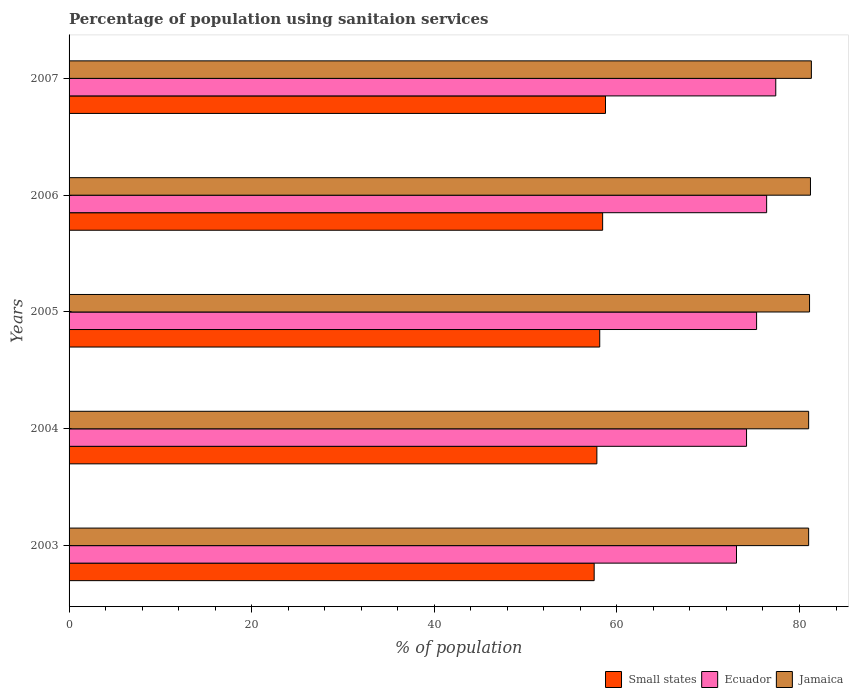How many different coloured bars are there?
Offer a terse response. 3. How many groups of bars are there?
Ensure brevity in your answer.  5. Are the number of bars per tick equal to the number of legend labels?
Keep it short and to the point. Yes. Are the number of bars on each tick of the Y-axis equal?
Ensure brevity in your answer.  Yes. How many bars are there on the 3rd tick from the bottom?
Provide a short and direct response. 3. In how many cases, is the number of bars for a given year not equal to the number of legend labels?
Your response must be concise. 0. What is the percentage of population using sanitaion services in Jamaica in 2006?
Your answer should be very brief. 81.2. Across all years, what is the maximum percentage of population using sanitaion services in Jamaica?
Keep it short and to the point. 81.3. Across all years, what is the minimum percentage of population using sanitaion services in Ecuador?
Give a very brief answer. 73.1. In which year was the percentage of population using sanitaion services in Ecuador maximum?
Make the answer very short. 2007. What is the total percentage of population using sanitaion services in Jamaica in the graph?
Your response must be concise. 405.6. What is the difference between the percentage of population using sanitaion services in Small states in 2005 and that in 2007?
Offer a very short reply. -0.63. What is the difference between the percentage of population using sanitaion services in Small states in 2006 and the percentage of population using sanitaion services in Ecuador in 2005?
Your answer should be very brief. -16.86. What is the average percentage of population using sanitaion services in Jamaica per year?
Make the answer very short. 81.12. In the year 2004, what is the difference between the percentage of population using sanitaion services in Jamaica and percentage of population using sanitaion services in Ecuador?
Your answer should be very brief. 6.8. In how many years, is the percentage of population using sanitaion services in Jamaica greater than 20 %?
Your answer should be compact. 5. What is the ratio of the percentage of population using sanitaion services in Small states in 2004 to that in 2006?
Offer a terse response. 0.99. What is the difference between the highest and the second highest percentage of population using sanitaion services in Small states?
Make the answer very short. 0.31. What is the difference between the highest and the lowest percentage of population using sanitaion services in Ecuador?
Keep it short and to the point. 4.3. What does the 2nd bar from the top in 2005 represents?
Your answer should be very brief. Ecuador. What does the 1st bar from the bottom in 2003 represents?
Provide a succinct answer. Small states. Does the graph contain grids?
Your response must be concise. No. Where does the legend appear in the graph?
Your answer should be very brief. Bottom right. What is the title of the graph?
Your answer should be very brief. Percentage of population using sanitaion services. What is the label or title of the X-axis?
Provide a succinct answer. % of population. What is the % of population of Small states in 2003?
Your answer should be compact. 57.51. What is the % of population of Ecuador in 2003?
Keep it short and to the point. 73.1. What is the % of population in Jamaica in 2003?
Your response must be concise. 81. What is the % of population in Small states in 2004?
Your response must be concise. 57.81. What is the % of population of Ecuador in 2004?
Your answer should be compact. 74.2. What is the % of population in Small states in 2005?
Give a very brief answer. 58.12. What is the % of population in Ecuador in 2005?
Your response must be concise. 75.3. What is the % of population of Jamaica in 2005?
Your answer should be very brief. 81.1. What is the % of population in Small states in 2006?
Keep it short and to the point. 58.44. What is the % of population of Ecuador in 2006?
Ensure brevity in your answer.  76.4. What is the % of population of Jamaica in 2006?
Provide a short and direct response. 81.2. What is the % of population of Small states in 2007?
Your response must be concise. 58.75. What is the % of population in Ecuador in 2007?
Keep it short and to the point. 77.4. What is the % of population in Jamaica in 2007?
Keep it short and to the point. 81.3. Across all years, what is the maximum % of population of Small states?
Keep it short and to the point. 58.75. Across all years, what is the maximum % of population of Ecuador?
Your response must be concise. 77.4. Across all years, what is the maximum % of population in Jamaica?
Your answer should be compact. 81.3. Across all years, what is the minimum % of population in Small states?
Your answer should be very brief. 57.51. Across all years, what is the minimum % of population in Ecuador?
Provide a succinct answer. 73.1. What is the total % of population of Small states in the graph?
Keep it short and to the point. 290.63. What is the total % of population in Ecuador in the graph?
Provide a succinct answer. 376.4. What is the total % of population in Jamaica in the graph?
Your answer should be compact. 405.6. What is the difference between the % of population of Small states in 2003 and that in 2004?
Keep it short and to the point. -0.3. What is the difference between the % of population of Small states in 2003 and that in 2005?
Your answer should be very brief. -0.61. What is the difference between the % of population of Ecuador in 2003 and that in 2005?
Keep it short and to the point. -2.2. What is the difference between the % of population in Jamaica in 2003 and that in 2005?
Keep it short and to the point. -0.1. What is the difference between the % of population of Small states in 2003 and that in 2006?
Keep it short and to the point. -0.93. What is the difference between the % of population of Jamaica in 2003 and that in 2006?
Provide a succinct answer. -0.2. What is the difference between the % of population in Small states in 2003 and that in 2007?
Your response must be concise. -1.24. What is the difference between the % of population of Ecuador in 2003 and that in 2007?
Your response must be concise. -4.3. What is the difference between the % of population of Jamaica in 2003 and that in 2007?
Your answer should be very brief. -0.3. What is the difference between the % of population of Small states in 2004 and that in 2005?
Offer a very short reply. -0.31. What is the difference between the % of population in Ecuador in 2004 and that in 2005?
Offer a terse response. -1.1. What is the difference between the % of population in Jamaica in 2004 and that in 2005?
Ensure brevity in your answer.  -0.1. What is the difference between the % of population of Small states in 2004 and that in 2006?
Your response must be concise. -0.63. What is the difference between the % of population in Ecuador in 2004 and that in 2006?
Keep it short and to the point. -2.2. What is the difference between the % of population in Small states in 2004 and that in 2007?
Offer a very short reply. -0.95. What is the difference between the % of population in Ecuador in 2004 and that in 2007?
Provide a succinct answer. -3.2. What is the difference between the % of population in Small states in 2005 and that in 2006?
Your response must be concise. -0.32. What is the difference between the % of population in Ecuador in 2005 and that in 2006?
Provide a short and direct response. -1.1. What is the difference between the % of population in Small states in 2005 and that in 2007?
Your answer should be compact. -0.63. What is the difference between the % of population in Small states in 2006 and that in 2007?
Make the answer very short. -0.31. What is the difference between the % of population of Ecuador in 2006 and that in 2007?
Keep it short and to the point. -1. What is the difference between the % of population in Jamaica in 2006 and that in 2007?
Keep it short and to the point. -0.1. What is the difference between the % of population in Small states in 2003 and the % of population in Ecuador in 2004?
Your response must be concise. -16.69. What is the difference between the % of population of Small states in 2003 and the % of population of Jamaica in 2004?
Ensure brevity in your answer.  -23.49. What is the difference between the % of population in Small states in 2003 and the % of population in Ecuador in 2005?
Your response must be concise. -17.79. What is the difference between the % of population in Small states in 2003 and the % of population in Jamaica in 2005?
Make the answer very short. -23.59. What is the difference between the % of population in Small states in 2003 and the % of population in Ecuador in 2006?
Offer a very short reply. -18.89. What is the difference between the % of population of Small states in 2003 and the % of population of Jamaica in 2006?
Ensure brevity in your answer.  -23.69. What is the difference between the % of population of Small states in 2003 and the % of population of Ecuador in 2007?
Provide a short and direct response. -19.89. What is the difference between the % of population in Small states in 2003 and the % of population in Jamaica in 2007?
Your answer should be compact. -23.79. What is the difference between the % of population in Small states in 2004 and the % of population in Ecuador in 2005?
Your answer should be compact. -17.49. What is the difference between the % of population in Small states in 2004 and the % of population in Jamaica in 2005?
Provide a short and direct response. -23.29. What is the difference between the % of population of Ecuador in 2004 and the % of population of Jamaica in 2005?
Your answer should be compact. -6.9. What is the difference between the % of population in Small states in 2004 and the % of population in Ecuador in 2006?
Give a very brief answer. -18.59. What is the difference between the % of population in Small states in 2004 and the % of population in Jamaica in 2006?
Give a very brief answer. -23.39. What is the difference between the % of population of Ecuador in 2004 and the % of population of Jamaica in 2006?
Ensure brevity in your answer.  -7. What is the difference between the % of population in Small states in 2004 and the % of population in Ecuador in 2007?
Give a very brief answer. -19.59. What is the difference between the % of population in Small states in 2004 and the % of population in Jamaica in 2007?
Ensure brevity in your answer.  -23.49. What is the difference between the % of population of Ecuador in 2004 and the % of population of Jamaica in 2007?
Ensure brevity in your answer.  -7.1. What is the difference between the % of population in Small states in 2005 and the % of population in Ecuador in 2006?
Give a very brief answer. -18.28. What is the difference between the % of population in Small states in 2005 and the % of population in Jamaica in 2006?
Make the answer very short. -23.08. What is the difference between the % of population of Small states in 2005 and the % of population of Ecuador in 2007?
Make the answer very short. -19.28. What is the difference between the % of population of Small states in 2005 and the % of population of Jamaica in 2007?
Give a very brief answer. -23.18. What is the difference between the % of population of Small states in 2006 and the % of population of Ecuador in 2007?
Ensure brevity in your answer.  -18.96. What is the difference between the % of population of Small states in 2006 and the % of population of Jamaica in 2007?
Ensure brevity in your answer.  -22.86. What is the difference between the % of population of Ecuador in 2006 and the % of population of Jamaica in 2007?
Your answer should be compact. -4.9. What is the average % of population in Small states per year?
Offer a terse response. 58.13. What is the average % of population of Ecuador per year?
Offer a very short reply. 75.28. What is the average % of population of Jamaica per year?
Offer a very short reply. 81.12. In the year 2003, what is the difference between the % of population of Small states and % of population of Ecuador?
Your answer should be very brief. -15.59. In the year 2003, what is the difference between the % of population in Small states and % of population in Jamaica?
Ensure brevity in your answer.  -23.49. In the year 2004, what is the difference between the % of population in Small states and % of population in Ecuador?
Keep it short and to the point. -16.39. In the year 2004, what is the difference between the % of population in Small states and % of population in Jamaica?
Your answer should be very brief. -23.19. In the year 2004, what is the difference between the % of population in Ecuador and % of population in Jamaica?
Provide a succinct answer. -6.8. In the year 2005, what is the difference between the % of population of Small states and % of population of Ecuador?
Your answer should be compact. -17.18. In the year 2005, what is the difference between the % of population of Small states and % of population of Jamaica?
Your response must be concise. -22.98. In the year 2005, what is the difference between the % of population of Ecuador and % of population of Jamaica?
Provide a short and direct response. -5.8. In the year 2006, what is the difference between the % of population of Small states and % of population of Ecuador?
Ensure brevity in your answer.  -17.96. In the year 2006, what is the difference between the % of population of Small states and % of population of Jamaica?
Your answer should be compact. -22.76. In the year 2006, what is the difference between the % of population of Ecuador and % of population of Jamaica?
Ensure brevity in your answer.  -4.8. In the year 2007, what is the difference between the % of population in Small states and % of population in Ecuador?
Keep it short and to the point. -18.65. In the year 2007, what is the difference between the % of population in Small states and % of population in Jamaica?
Make the answer very short. -22.55. In the year 2007, what is the difference between the % of population of Ecuador and % of population of Jamaica?
Make the answer very short. -3.9. What is the ratio of the % of population in Small states in 2003 to that in 2004?
Keep it short and to the point. 0.99. What is the ratio of the % of population in Ecuador in 2003 to that in 2004?
Ensure brevity in your answer.  0.99. What is the ratio of the % of population of Ecuador in 2003 to that in 2005?
Offer a terse response. 0.97. What is the ratio of the % of population in Small states in 2003 to that in 2006?
Give a very brief answer. 0.98. What is the ratio of the % of population of Ecuador in 2003 to that in 2006?
Provide a short and direct response. 0.96. What is the ratio of the % of population in Jamaica in 2003 to that in 2006?
Provide a short and direct response. 1. What is the ratio of the % of population of Small states in 2003 to that in 2007?
Your answer should be very brief. 0.98. What is the ratio of the % of population in Ecuador in 2003 to that in 2007?
Offer a terse response. 0.94. What is the ratio of the % of population in Jamaica in 2003 to that in 2007?
Provide a short and direct response. 1. What is the ratio of the % of population in Ecuador in 2004 to that in 2005?
Ensure brevity in your answer.  0.99. What is the ratio of the % of population of Jamaica in 2004 to that in 2005?
Offer a terse response. 1. What is the ratio of the % of population in Ecuador in 2004 to that in 2006?
Keep it short and to the point. 0.97. What is the ratio of the % of population of Jamaica in 2004 to that in 2006?
Your answer should be compact. 1. What is the ratio of the % of population of Small states in 2004 to that in 2007?
Your answer should be very brief. 0.98. What is the ratio of the % of population of Ecuador in 2004 to that in 2007?
Provide a succinct answer. 0.96. What is the ratio of the % of population in Small states in 2005 to that in 2006?
Keep it short and to the point. 0.99. What is the ratio of the % of population in Ecuador in 2005 to that in 2006?
Your response must be concise. 0.99. What is the ratio of the % of population of Jamaica in 2005 to that in 2006?
Offer a very short reply. 1. What is the ratio of the % of population of Ecuador in 2005 to that in 2007?
Your answer should be compact. 0.97. What is the ratio of the % of population in Jamaica in 2005 to that in 2007?
Your answer should be compact. 1. What is the ratio of the % of population in Small states in 2006 to that in 2007?
Ensure brevity in your answer.  0.99. What is the ratio of the % of population in Ecuador in 2006 to that in 2007?
Provide a short and direct response. 0.99. What is the difference between the highest and the second highest % of population of Small states?
Your response must be concise. 0.31. What is the difference between the highest and the second highest % of population in Ecuador?
Offer a terse response. 1. What is the difference between the highest and the second highest % of population of Jamaica?
Your answer should be very brief. 0.1. What is the difference between the highest and the lowest % of population in Small states?
Offer a very short reply. 1.24. What is the difference between the highest and the lowest % of population of Ecuador?
Offer a terse response. 4.3. What is the difference between the highest and the lowest % of population in Jamaica?
Provide a short and direct response. 0.3. 